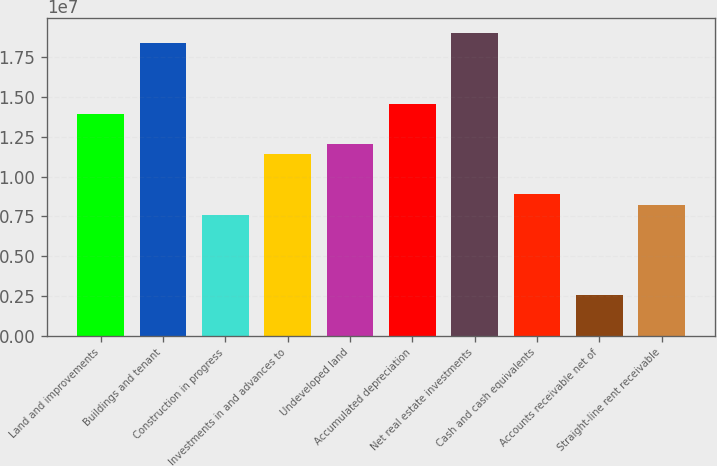Convert chart. <chart><loc_0><loc_0><loc_500><loc_500><bar_chart><fcel>Land and improvements<fcel>Buildings and tenant<fcel>Construction in progress<fcel>Investments in and advances to<fcel>Undeveloped land<fcel>Accumulated depreciation<fcel>Net real estate investments<fcel>Cash and cash equivalents<fcel>Accounts receivable net of<fcel>Straight-line rent receivable<nl><fcel>1.39531e+07<fcel>1.8392e+07<fcel>7.61179e+06<fcel>1.14166e+07<fcel>1.20507e+07<fcel>1.45872e+07<fcel>1.90261e+07<fcel>8.88004e+06<fcel>2.53876e+06<fcel>8.24591e+06<nl></chart> 